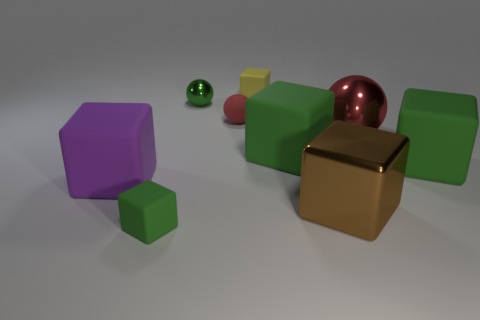What is the shape of the red metal thing that is the same size as the brown metal cube?
Offer a terse response. Sphere. How many tiny green rubber cubes are in front of the rubber thing in front of the object that is on the left side of the tiny green matte block?
Make the answer very short. 0. How many metal things are green cubes or big gray balls?
Ensure brevity in your answer.  0. What color is the shiny object that is right of the small yellow object and behind the big metallic cube?
Give a very brief answer. Red. There is a green object that is to the right of the brown object; does it have the same size as the green metal ball?
Make the answer very short. No. How many objects are either big rubber blocks behind the purple matte block or tiny red matte balls?
Keep it short and to the point. 3. Are there any gray metallic balls that have the same size as the red metal sphere?
Provide a succinct answer. No. What material is the red thing that is the same size as the green shiny object?
Provide a short and direct response. Rubber. There is a object that is to the left of the small metallic ball and in front of the purple rubber object; what is its shape?
Your answer should be compact. Cube. The big block that is left of the small yellow matte object is what color?
Keep it short and to the point. Purple. 